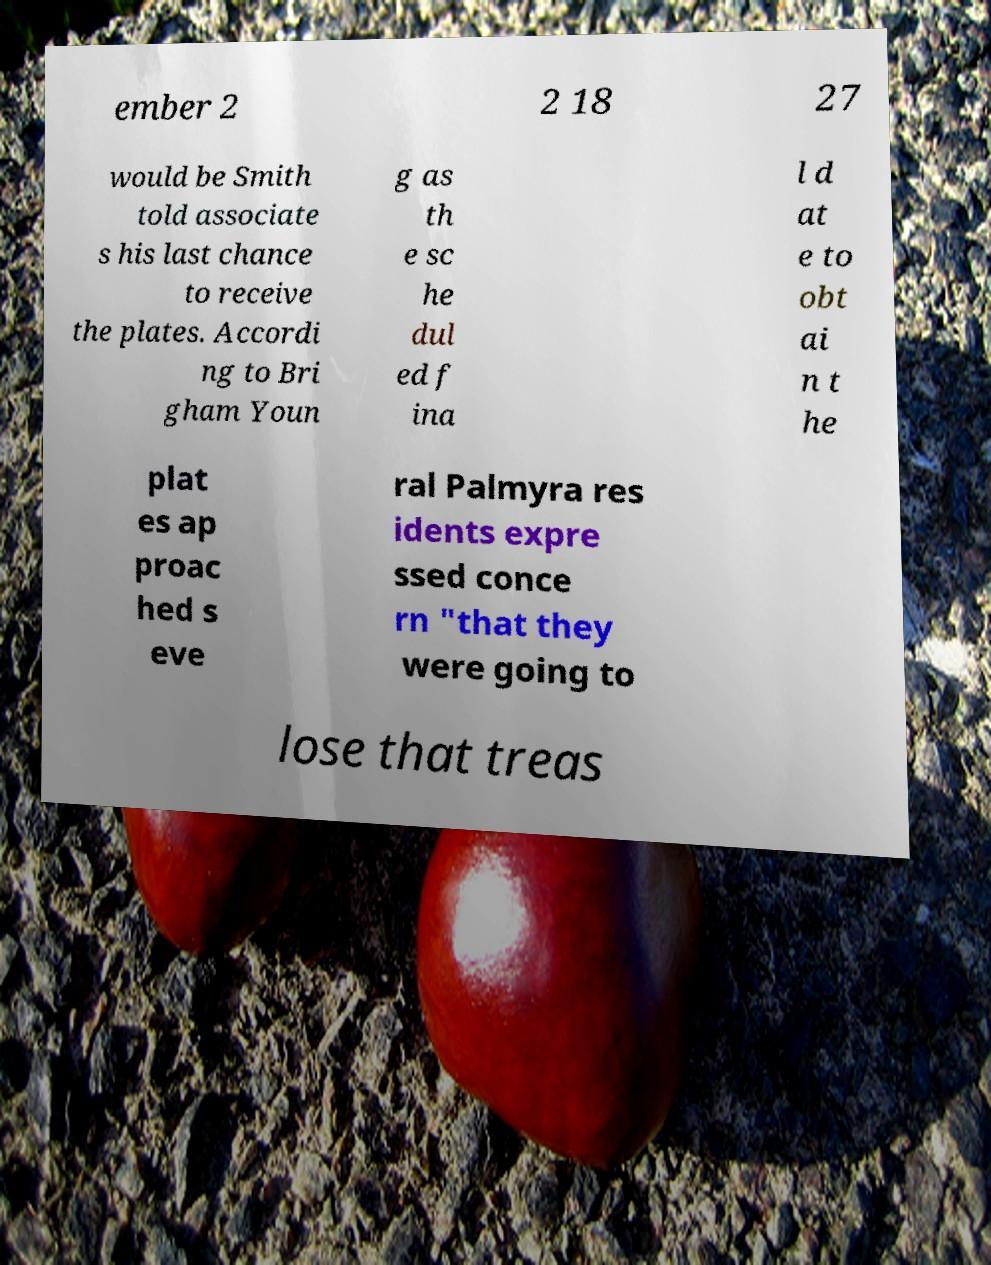I need the written content from this picture converted into text. Can you do that? ember 2 2 18 27 would be Smith told associate s his last chance to receive the plates. Accordi ng to Bri gham Youn g as th e sc he dul ed f ina l d at e to obt ai n t he plat es ap proac hed s eve ral Palmyra res idents expre ssed conce rn "that they were going to lose that treas 